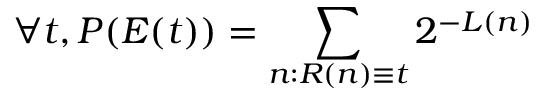<formula> <loc_0><loc_0><loc_500><loc_500>\forall t , P ( E ( t ) ) = \sum _ { n \colon R ( n ) \equiv t } 2 ^ { - L ( n ) }</formula> 